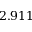<formula> <loc_0><loc_0><loc_500><loc_500>2 . 9 1 1</formula> 